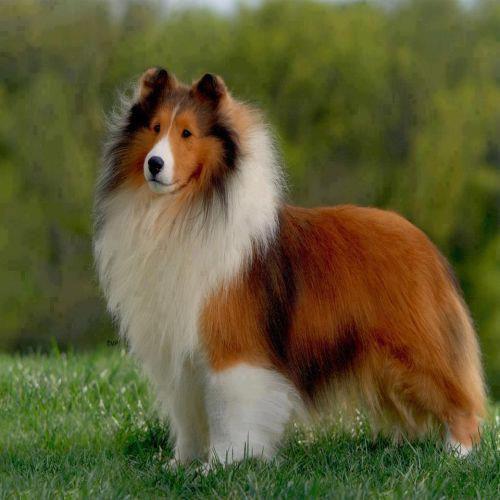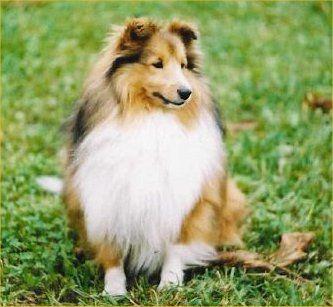The first image is the image on the left, the second image is the image on the right. For the images shown, is this caption "The dog in one of the images is sitting and looking toward the camera." true? Answer yes or no. No. 